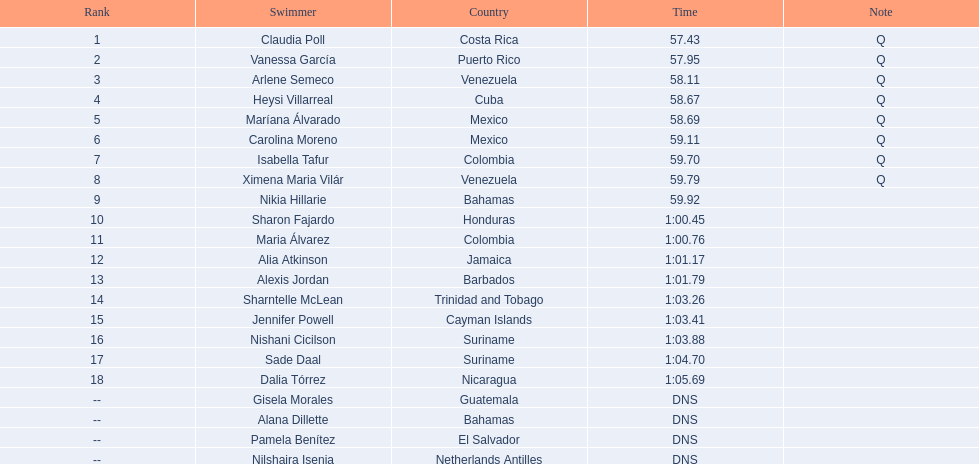What was claudia roll's time? 57.43. 